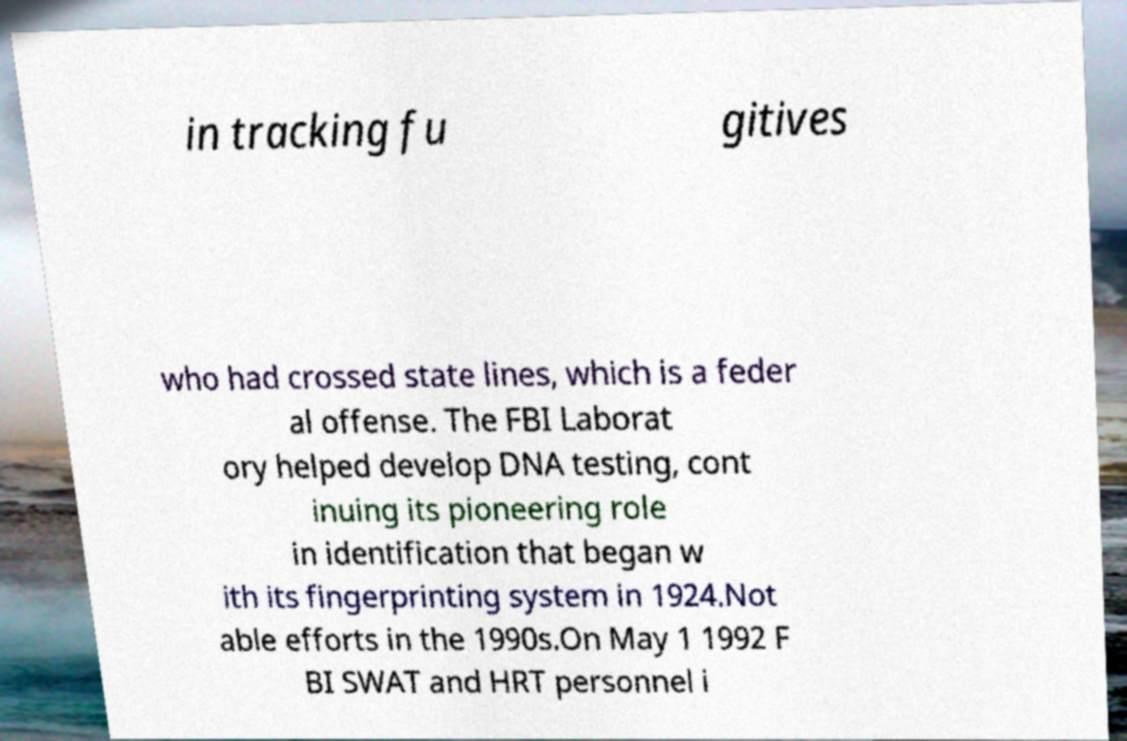There's text embedded in this image that I need extracted. Can you transcribe it verbatim? in tracking fu gitives who had crossed state lines, which is a feder al offense. The FBI Laborat ory helped develop DNA testing, cont inuing its pioneering role in identification that began w ith its fingerprinting system in 1924.Not able efforts in the 1990s.On May 1 1992 F BI SWAT and HRT personnel i 